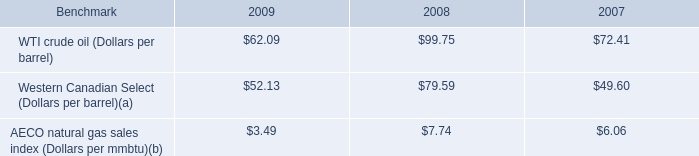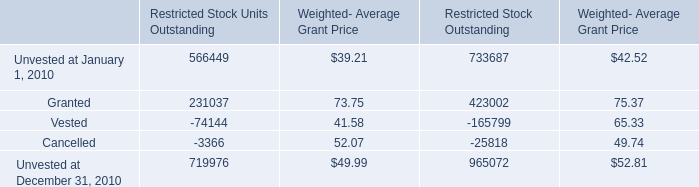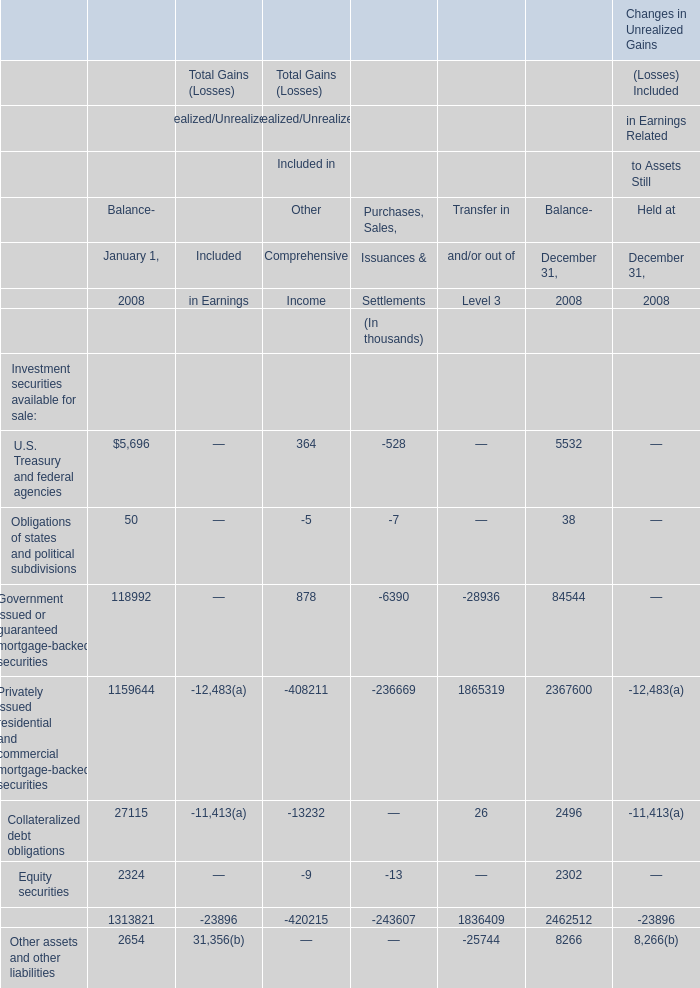What was the total amount of the U.S. Treasury and federal agencies in the sections where Obligations of states and political subdivisions is greater than 0? (in thousand) 
Computations: (5696 + 5532)
Answer: 11228.0. 